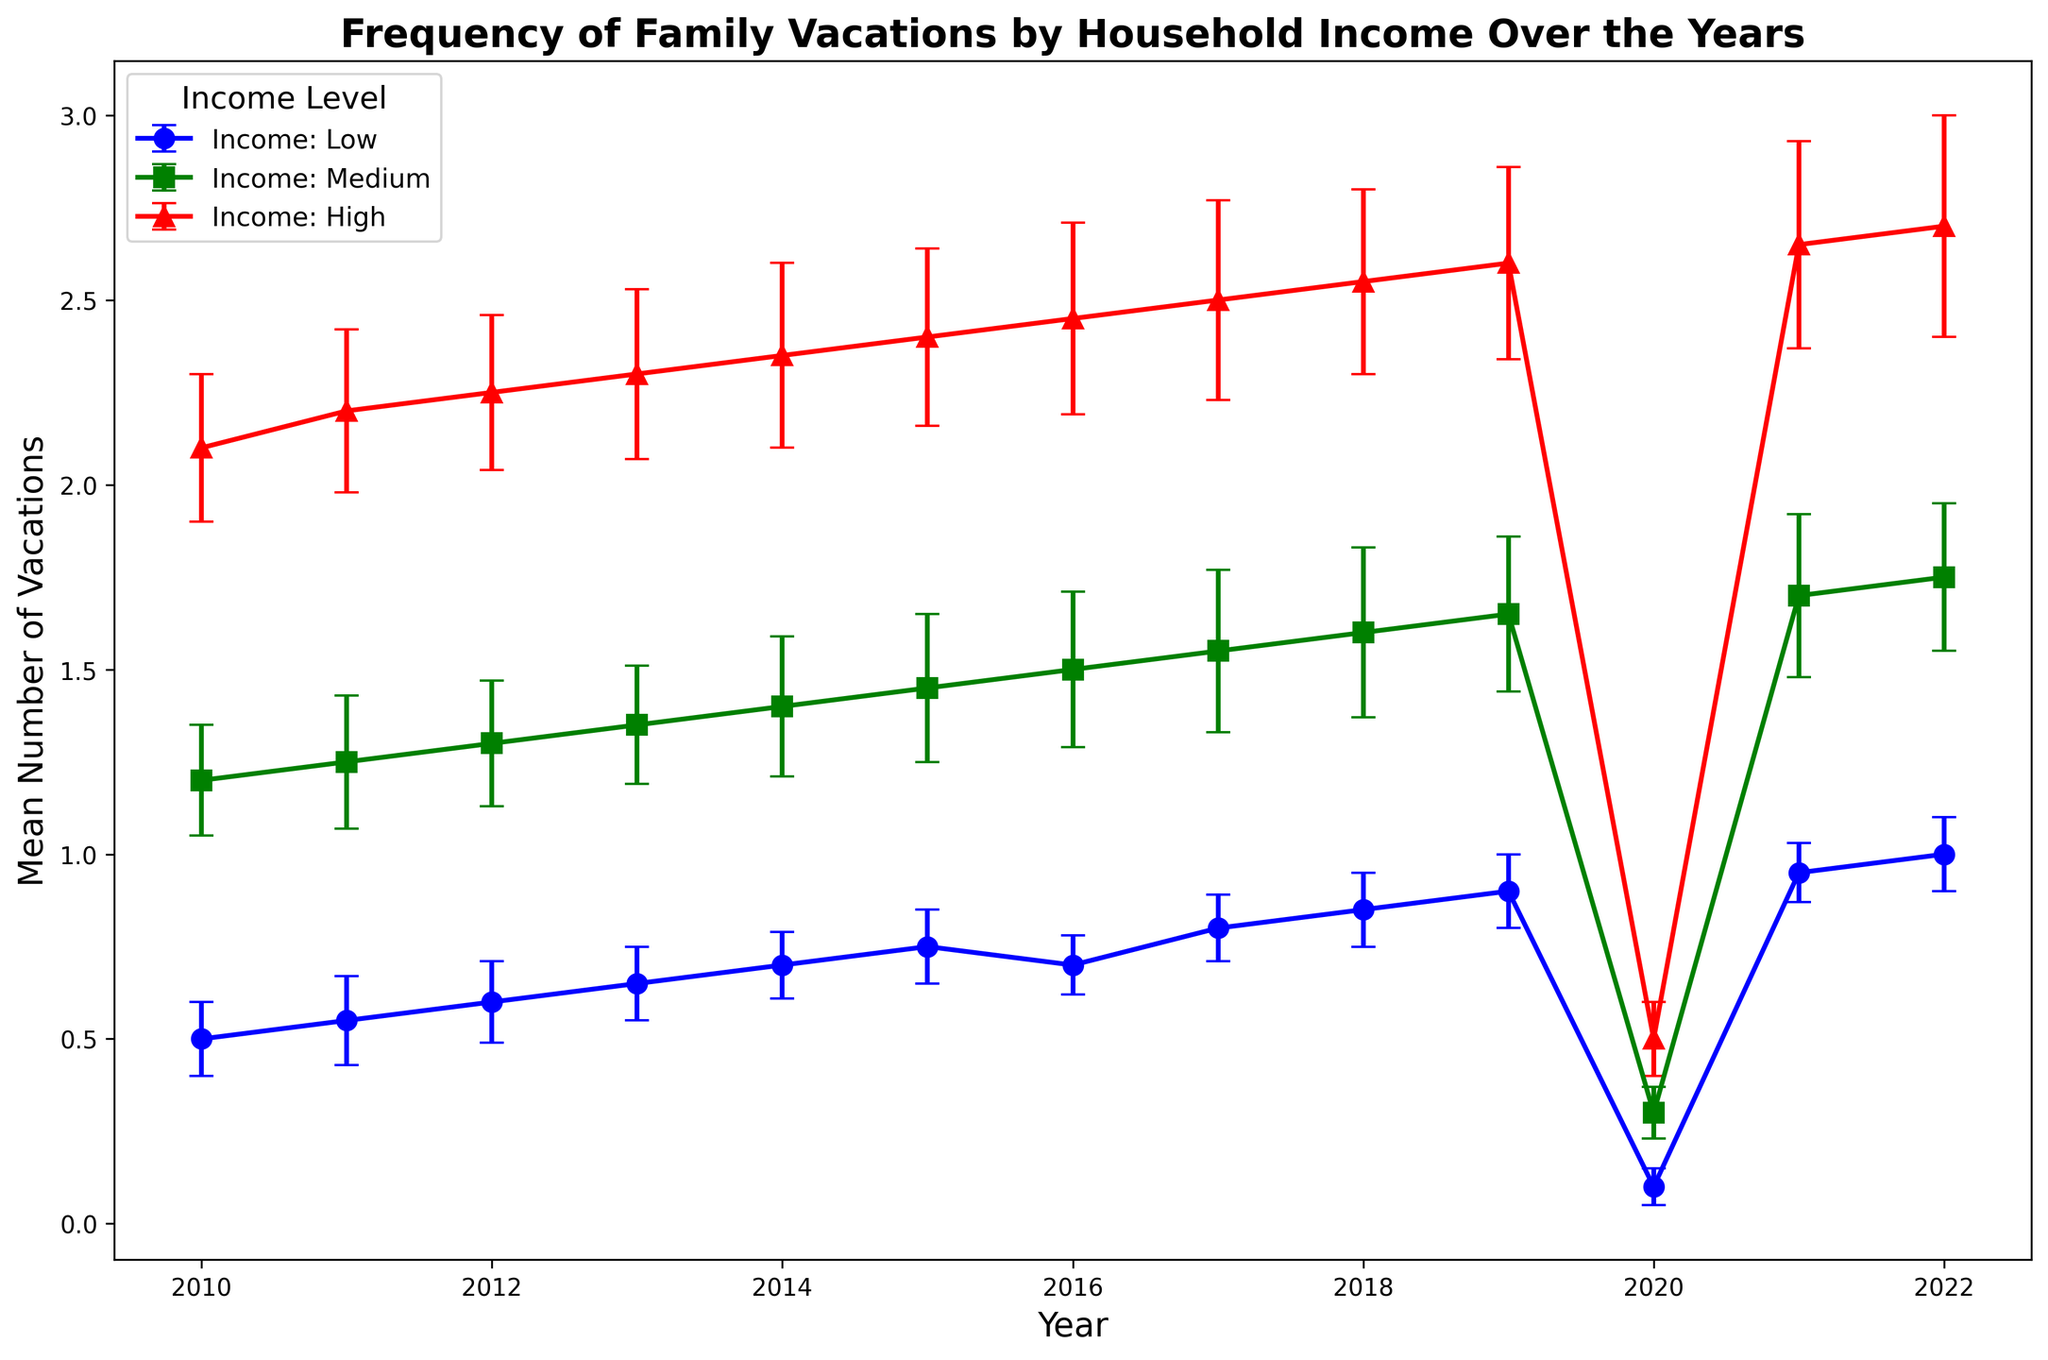Which household income level had the highest mean number of vacations in 2022? Look for the highest value in the plot for the year 2022 across all income levels. The "High" income level shows the highest mean number of vacations.
Answer: High What is the trend in the mean number of vacations for the low-income group from 2010 to 2022? Follow the blue points representing the Low-income group from 2010 to 2022; the trend shows a general increase, except for a sharp drop in 2020.
Answer: Increasing trend with a drop in 2020 By how much did the mean number of vacations for the medium-income group drop from 2019 to 2020? Examine the green line for Medium income: in 2019, it is at 1.65, and in 2020, it is at 0.3. The difference is 1.65 - 0.3.
Answer: 1.35 Which year shows the greatest decrease in mean vacations across all income levels? Observe all three lines to determine the year with the most significant drop. The year 2020 across all lines (blue, green, red) shows the steepest decrease.
Answer: 2020 In 2015, how do the number of vacations for high-income households compare to those for medium-income households? Observe the red and green points for the year 2015. The high-income group has a value of 2.4, and the medium-income group has a value of 1.45, indicating the high-income group has more vacations.
Answer: High-income > Medium-income What is the average mean number of vacations for the high-income household from 2017 to 2021? Sum the values for the high-income group from 2017 (2.5), 2018 (2.55), 2019 (2.6), 2020 (0.5), and 2021 (2.65). Then divide by the number of years (5). The calculation is (2.5 + 2.55 + 2.6 + 0.5 + 2.65) / 5.
Answer: 2.16 How does the variability in the mean number of vacations compare across income groups in 2020? Compare the error bars for all income groups in 2020; the low-income group has the smallest variability, while the high-income group has the largest.
Answer: Low < Medium < High 